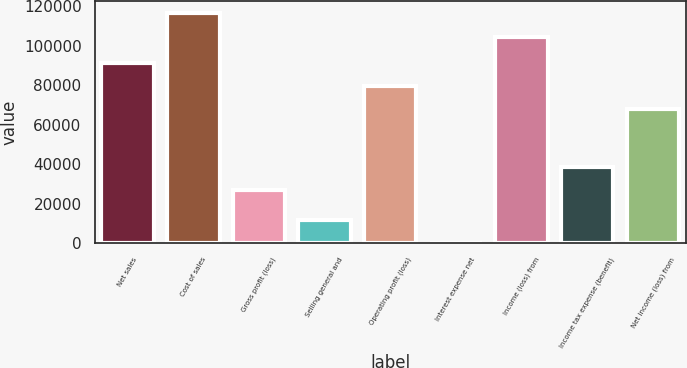Convert chart to OTSL. <chart><loc_0><loc_0><loc_500><loc_500><bar_chart><fcel>Net sales<fcel>Cost of sales<fcel>Gross profit (loss)<fcel>Selling general and<fcel>Operating profit (loss)<fcel>Interest expense net<fcel>Income (loss) from<fcel>Income tax expense (benefit)<fcel>Net income (loss) from<nl><fcel>91120.6<fcel>116798<fcel>27112<fcel>11684.3<fcel>79441.3<fcel>5<fcel>104571<fcel>38791.3<fcel>67762<nl></chart> 